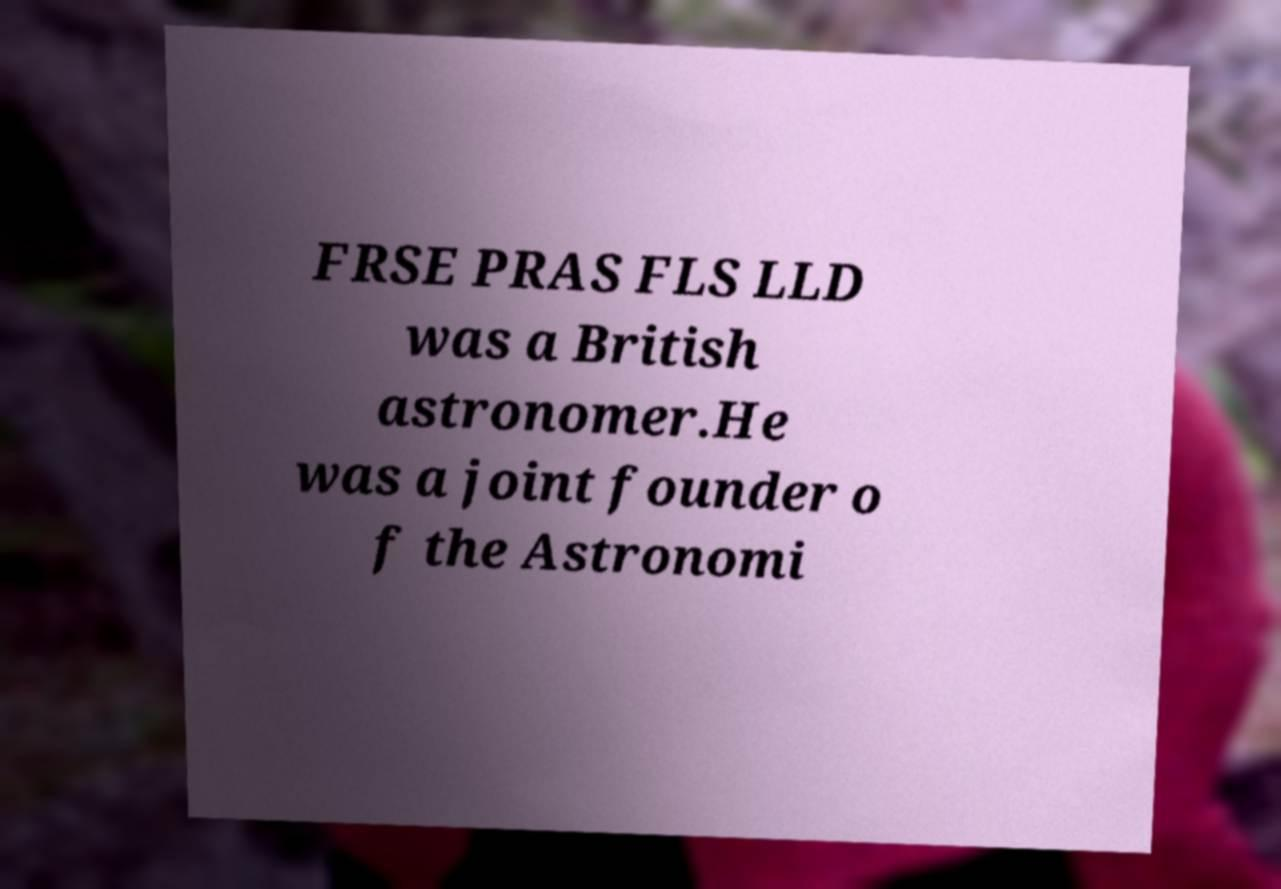I need the written content from this picture converted into text. Can you do that? FRSE PRAS FLS LLD was a British astronomer.He was a joint founder o f the Astronomi 